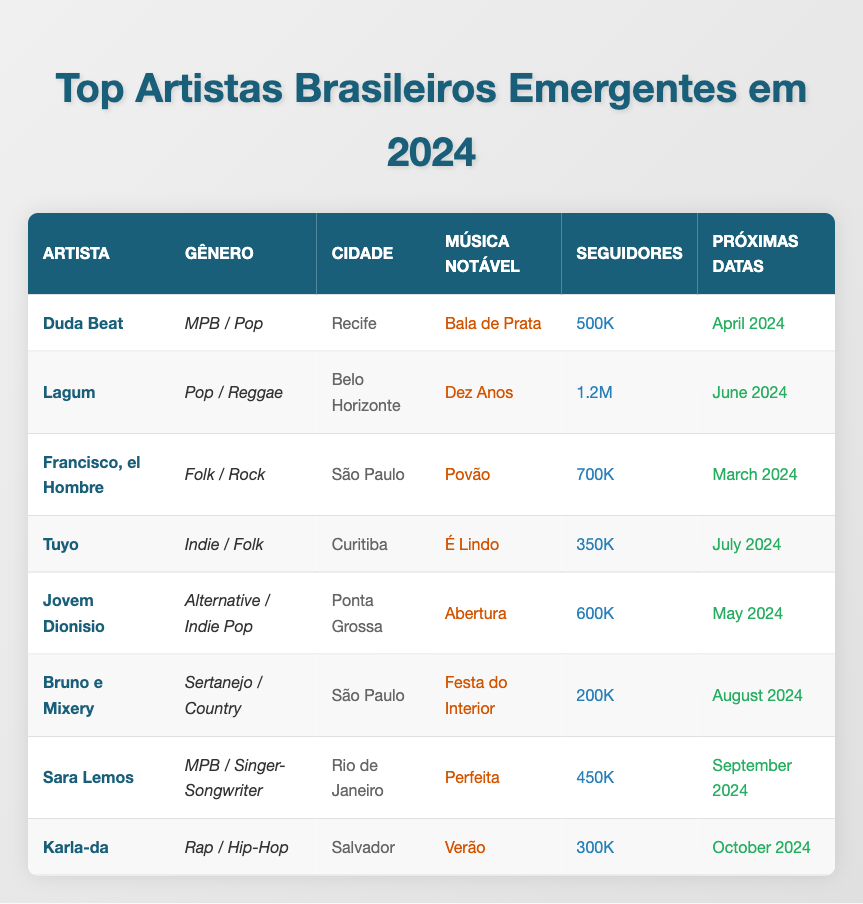What is the genre of Duda Beat? The table lists Duda Beat's genre in the corresponding column, which is "MPB / Pop."
Answer: MPB / Pop Which city is Karla-da from? By checking the city column in the table for Karla-da, it shows she is from "Salvador."
Answer: Salvador How many social media followers does Lagum have? The social media followers for Lagum can be found in the table, indicating he has "1.2M" followers.
Answer: 1.2M What notable song does Francisco, el Hombre have? The table specifies that Francisco, el Hombre's notable song is "Povão."
Answer: Povão What is the upcoming tour date for Sara Lemos? Referring to the tour dates column for Sara Lemos, it is listed as "September 2024."
Answer: September 2024 Which artist has the fewest social media followers? By comparing the social media followers across all artists, Bruno e Mixery has the fewest with "200K."
Answer: Bruno e Mixery What is the average number of social media followers for the listed artists? Adding up all the social media followers: (500K + 1.2M + 700K + 350K + 600K + 200K + 450K + 300K) = 4.3M. There are 8 artists, so the average is 4.3M / 8 = 537.5K.
Answer: 537.5K Is Tuyo's genre Indie / Folk? Checking the genre column for Tuyo, it is listed as "Indie / Folk." Therefore, the statement is true.
Answer: Yes Which artist from São Paulo has a notable song called "Festa do Interior"? The provided data indicates that "Bruno e Mixery" is the artist from São Paulo with that notable song.
Answer: Bruno e Mixery How many artists have their upcoming tour in April 2024? Looking at the upcoming tour dates, only Duda Beat has a tour scheduled for April 2024, making the count one artist.
Answer: 1 